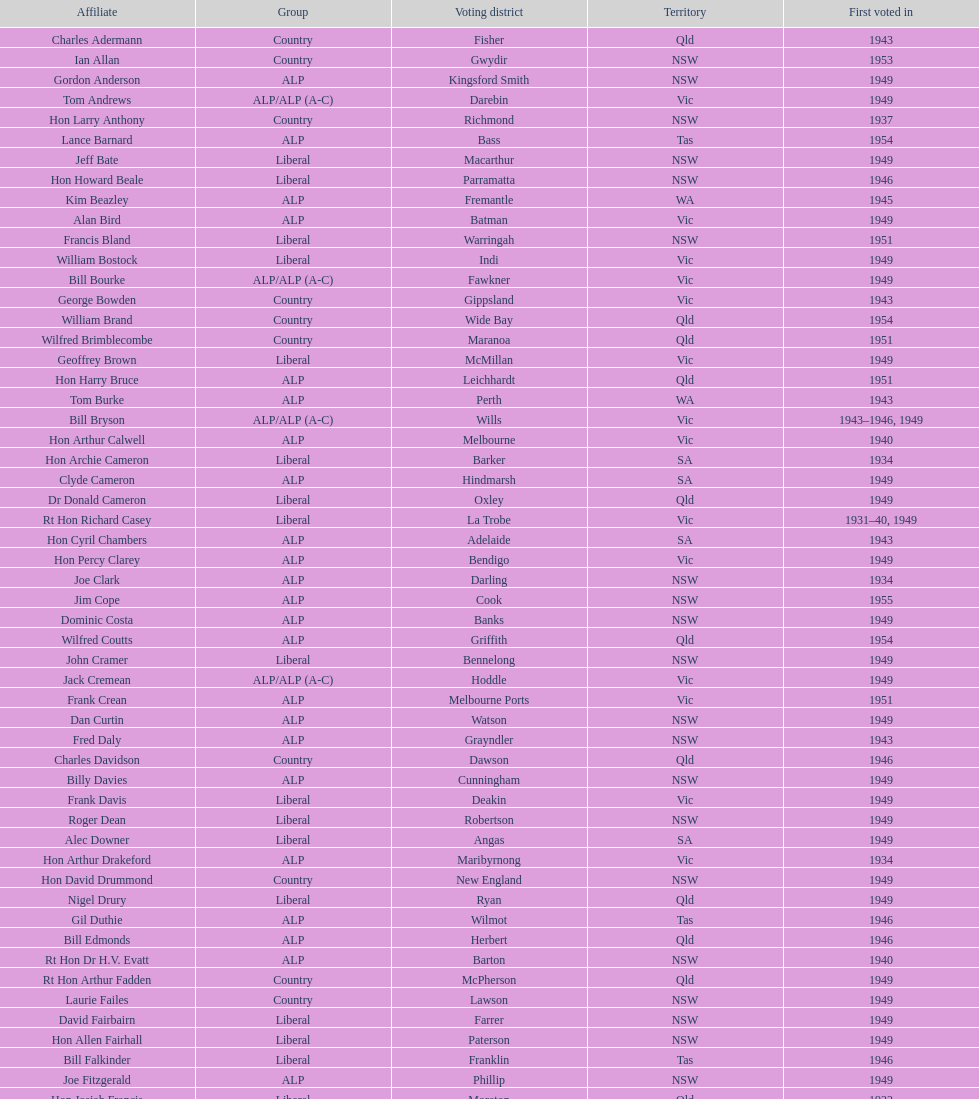Parse the table in full. {'header': ['Affiliate', 'Group', 'Voting district', 'Territory', 'First voted in'], 'rows': [['Charles Adermann', 'Country', 'Fisher', 'Qld', '1943'], ['Ian Allan', 'Country', 'Gwydir', 'NSW', '1953'], ['Gordon Anderson', 'ALP', 'Kingsford Smith', 'NSW', '1949'], ['Tom Andrews', 'ALP/ALP (A-C)', 'Darebin', 'Vic', '1949'], ['Hon Larry Anthony', 'Country', 'Richmond', 'NSW', '1937'], ['Lance Barnard', 'ALP', 'Bass', 'Tas', '1954'], ['Jeff Bate', 'Liberal', 'Macarthur', 'NSW', '1949'], ['Hon Howard Beale', 'Liberal', 'Parramatta', 'NSW', '1946'], ['Kim Beazley', 'ALP', 'Fremantle', 'WA', '1945'], ['Alan Bird', 'ALP', 'Batman', 'Vic', '1949'], ['Francis Bland', 'Liberal', 'Warringah', 'NSW', '1951'], ['William Bostock', 'Liberal', 'Indi', 'Vic', '1949'], ['Bill Bourke', 'ALP/ALP (A-C)', 'Fawkner', 'Vic', '1949'], ['George Bowden', 'Country', 'Gippsland', 'Vic', '1943'], ['William Brand', 'Country', 'Wide Bay', 'Qld', '1954'], ['Wilfred Brimblecombe', 'Country', 'Maranoa', 'Qld', '1951'], ['Geoffrey Brown', 'Liberal', 'McMillan', 'Vic', '1949'], ['Hon Harry Bruce', 'ALP', 'Leichhardt', 'Qld', '1951'], ['Tom Burke', 'ALP', 'Perth', 'WA', '1943'], ['Bill Bryson', 'ALP/ALP (A-C)', 'Wills', 'Vic', '1943–1946, 1949'], ['Hon Arthur Calwell', 'ALP', 'Melbourne', 'Vic', '1940'], ['Hon Archie Cameron', 'Liberal', 'Barker', 'SA', '1934'], ['Clyde Cameron', 'ALP', 'Hindmarsh', 'SA', '1949'], ['Dr Donald Cameron', 'Liberal', 'Oxley', 'Qld', '1949'], ['Rt Hon Richard Casey', 'Liberal', 'La Trobe', 'Vic', '1931–40, 1949'], ['Hon Cyril Chambers', 'ALP', 'Adelaide', 'SA', '1943'], ['Hon Percy Clarey', 'ALP', 'Bendigo', 'Vic', '1949'], ['Joe Clark', 'ALP', 'Darling', 'NSW', '1934'], ['Jim Cope', 'ALP', 'Cook', 'NSW', '1955'], ['Dominic Costa', 'ALP', 'Banks', 'NSW', '1949'], ['Wilfred Coutts', 'ALP', 'Griffith', 'Qld', '1954'], ['John Cramer', 'Liberal', 'Bennelong', 'NSW', '1949'], ['Jack Cremean', 'ALP/ALP (A-C)', 'Hoddle', 'Vic', '1949'], ['Frank Crean', 'ALP', 'Melbourne Ports', 'Vic', '1951'], ['Dan Curtin', 'ALP', 'Watson', 'NSW', '1949'], ['Fred Daly', 'ALP', 'Grayndler', 'NSW', '1943'], ['Charles Davidson', 'Country', 'Dawson', 'Qld', '1946'], ['Billy Davies', 'ALP', 'Cunningham', 'NSW', '1949'], ['Frank Davis', 'Liberal', 'Deakin', 'Vic', '1949'], ['Roger Dean', 'Liberal', 'Robertson', 'NSW', '1949'], ['Alec Downer', 'Liberal', 'Angas', 'SA', '1949'], ['Hon Arthur Drakeford', 'ALP', 'Maribyrnong', 'Vic', '1934'], ['Hon David Drummond', 'Country', 'New England', 'NSW', '1949'], ['Nigel Drury', 'Liberal', 'Ryan', 'Qld', '1949'], ['Gil Duthie', 'ALP', 'Wilmot', 'Tas', '1946'], ['Bill Edmonds', 'ALP', 'Herbert', 'Qld', '1946'], ['Rt Hon Dr H.V. Evatt', 'ALP', 'Barton', 'NSW', '1940'], ['Rt Hon Arthur Fadden', 'Country', 'McPherson', 'Qld', '1949'], ['Laurie Failes', 'Country', 'Lawson', 'NSW', '1949'], ['David Fairbairn', 'Liberal', 'Farrer', 'NSW', '1949'], ['Hon Allen Fairhall', 'Liberal', 'Paterson', 'NSW', '1949'], ['Bill Falkinder', 'Liberal', 'Franklin', 'Tas', '1946'], ['Joe Fitzgerald', 'ALP', 'Phillip', 'NSW', '1949'], ['Hon Josiah Francis', 'Liberal', 'Moreton', 'Qld', '1922'], ['Allan Fraser', 'ALP', 'Eden-Monaro', 'NSW', '1943'], ['Jim Fraser', 'ALP', 'Australian Capital Territory', 'ACT', '1951'], ['Gordon Freeth', 'Liberal', 'Forrest', 'WA', '1949'], ['Arthur Fuller', 'Country', 'Hume', 'NSW', '1943–49, 1951'], ['Pat Galvin', 'ALP', 'Kingston', 'SA', '1951'], ['Arthur Greenup', 'ALP', 'Dalley', 'NSW', '1953'], ['Charles Griffiths', 'ALP', 'Shortland', 'NSW', '1949'], ['Jo Gullett', 'Liberal', 'Henty', 'Vic', '1946'], ['Len Hamilton', 'Country', 'Canning', 'WA', '1946'], ['Rt Hon Eric Harrison', 'Liberal', 'Wentworth', 'NSW', '1931'], ['Jim Harrison', 'ALP', 'Blaxland', 'NSW', '1949'], ['Hon Paul Hasluck', 'Liberal', 'Curtin', 'WA', '1949'], ['Hon William Haworth', 'Liberal', 'Isaacs', 'Vic', '1949'], ['Leslie Haylen', 'ALP', 'Parkes', 'NSW', '1943'], ['Rt Hon Harold Holt', 'Liberal', 'Higgins', 'Vic', '1935'], ['John Howse', 'Liberal', 'Calare', 'NSW', '1946'], ['Alan Hulme', 'Liberal', 'Petrie', 'Qld', '1949'], ['William Jack', 'Liberal', 'North Sydney', 'NSW', '1949'], ['Rowley James', 'ALP', 'Hunter', 'NSW', '1928'], ['Hon Herbert Johnson', 'ALP', 'Kalgoorlie', 'WA', '1940'], ['Bob Joshua', 'ALP/ALP (A-C)', 'Ballaarat', 'ALP', '1951'], ['Percy Joske', 'Liberal', 'Balaclava', 'Vic', '1951'], ['Hon Wilfrid Kent Hughes', 'Liberal', 'Chisholm', 'Vic', '1949'], ['Stan Keon', 'ALP/ALP (A-C)', 'Yarra', 'Vic', '1949'], ['William Lawrence', 'Liberal', 'Wimmera', 'Vic', '1949'], ['Hon George Lawson', 'ALP', 'Brisbane', 'Qld', '1931'], ['Nelson Lemmon', 'ALP', 'St George', 'NSW', '1943–49, 1954'], ['Hugh Leslie', 'Liberal', 'Moore', 'Country', '1949'], ['Robert Lindsay', 'Liberal', 'Flinders', 'Vic', '1954'], ['Tony Luchetti', 'ALP', 'Macquarie', 'NSW', '1951'], ['Aubrey Luck', 'Liberal', 'Darwin', 'Tas', '1951'], ['Philip Lucock', 'Country', 'Lyne', 'NSW', '1953'], ['Dan Mackinnon', 'Liberal', 'Corangamite', 'Vic', '1949–51, 1953'], ['Hon Norman Makin', 'ALP', 'Sturt', 'SA', '1919–46, 1954'], ['Hon Philip McBride', 'Liberal', 'Wakefield', 'SA', '1931–37, 1937–43 (S), 1946'], ['Malcolm McColm', 'Liberal', 'Bowman', 'Qld', '1949'], ['Rt Hon John McEwen', 'Country', 'Murray', 'Vic', '1934'], ['John McLeay', 'Liberal', 'Boothby', 'SA', '1949'], ['Don McLeod', 'Liberal', 'Wannon', 'ALP', '1940–49, 1951'], ['Hon William McMahon', 'Liberal', 'Lowe', 'NSW', '1949'], ['Rt Hon Robert Menzies', 'Liberal', 'Kooyong', 'Vic', '1934'], ['Dan Minogue', 'ALP', 'West Sydney', 'NSW', '1949'], ['Charles Morgan', 'ALP', 'Reid', 'NSW', '1940–46, 1949'], ['Jack Mullens', 'ALP/ALP (A-C)', 'Gellibrand', 'Vic', '1949'], ['Jock Nelson', 'ALP', 'Northern Territory', 'NT', '1949'], ["William O'Connor", 'ALP', 'Martin', 'NSW', '1946'], ['Hubert Opperman', 'Liberal', 'Corio', 'Vic', '1949'], ['Hon Frederick Osborne', 'Liberal', 'Evans', 'NSW', '1949'], ['Rt Hon Sir Earle Page', 'Country', 'Cowper', 'NSW', '1919'], ['Henry Pearce', 'Liberal', 'Capricornia', 'Qld', '1949'], ['Ted Peters', 'ALP', 'Burke', 'Vic', '1949'], ['Hon Reg Pollard', 'ALP', 'Lalor', 'Vic', '1937'], ['Hon Bill Riordan', 'ALP', 'Kennedy', 'Qld', '1936'], ['Hugh Roberton', 'Country', 'Riverina', 'NSW', '1949'], ['Edgar Russell', 'ALP', 'Grey', 'SA', '1943'], ['Tom Sheehan', 'ALP', 'Cook', 'NSW', '1937'], ['Frank Stewart', 'ALP', 'Lang', 'NSW', '1953'], ['Reginald Swartz', 'Liberal', 'Darling Downs', 'Qld', '1949'], ['Albert Thompson', 'ALP', 'Port Adelaide', 'SA', '1946'], ['Frank Timson', 'Liberal', 'Higinbotham', 'Vic', '1949'], ['Hon Athol Townley', 'Liberal', 'Denison', 'Tas', '1949'], ['Winton Turnbull', 'Country', 'Mallee', 'Vic', '1946'], ['Harry Turner', 'Liberal', 'Bradfield', 'NSW', '1952'], ['Hon Eddie Ward', 'ALP', 'East Sydney', 'NSW', '1931, 1932'], ['David Oliver Watkins', 'ALP', 'Newcastle', 'NSW', '1935'], ['Harry Webb', 'ALP', 'Swan', 'WA', '1954'], ['William Wentworth', 'Liberal', 'Mackellar', 'NSW', '1949'], ['Roy Wheeler', 'Liberal', 'Mitchell', 'NSW', '1949'], ['Gough Whitlam', 'ALP', 'Werriwa', 'NSW', '1952'], ['Bruce Wight', 'Liberal', 'Lilley', 'Qld', '1949']]} After tom burke was elected, what was the next year where another tom would be elected? 1937. 